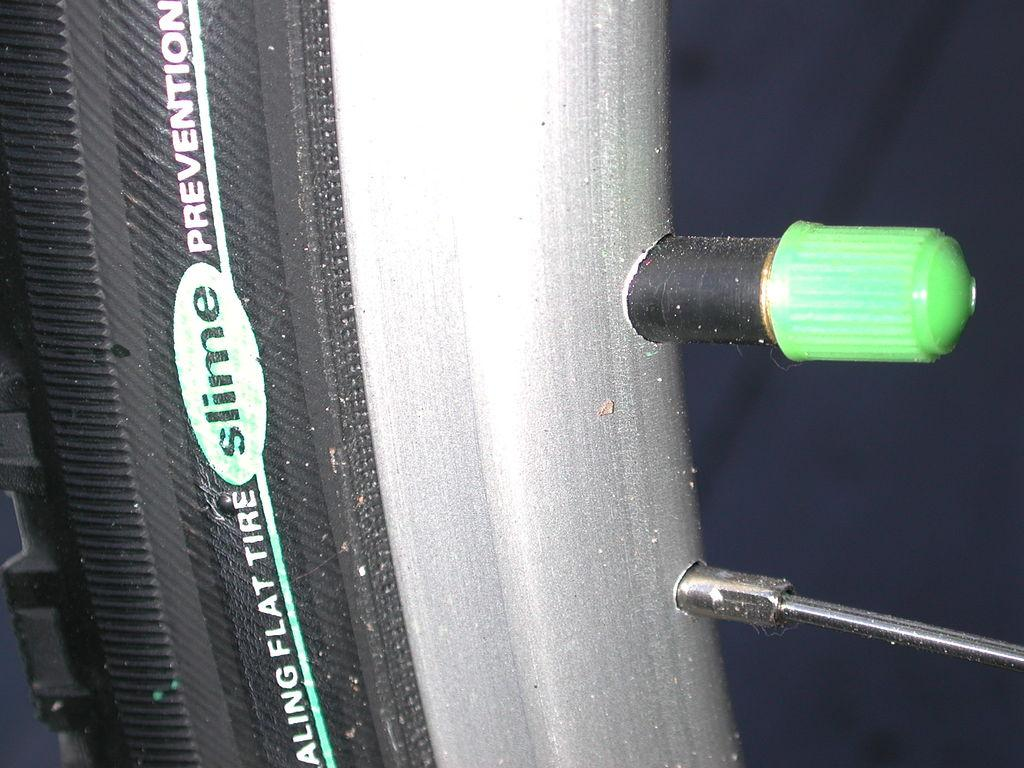<image>
Summarize the visual content of the image. A bicycle tire is filled with slime brand flat prevention. 